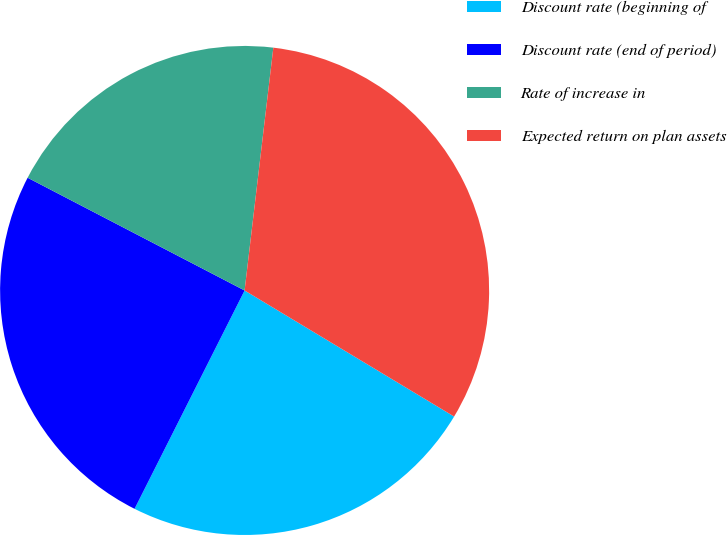Convert chart. <chart><loc_0><loc_0><loc_500><loc_500><pie_chart><fcel>Discount rate (beginning of<fcel>Discount rate (end of period)<fcel>Rate of increase in<fcel>Expected return on plan assets<nl><fcel>23.81%<fcel>25.2%<fcel>19.25%<fcel>31.75%<nl></chart> 